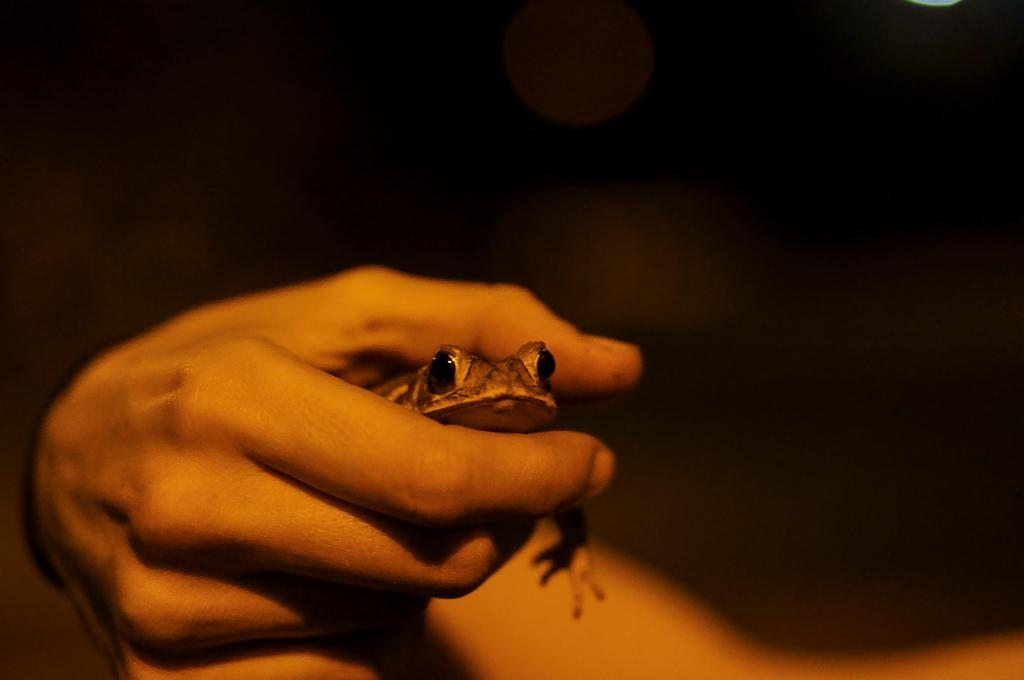What is the main subject of the image? The main subject of the image is a person. What is the person holding in the image? The person is holding a frog. What is the color of the background in the image? The background of the image is black. How does the person in the image end the frog's life? There is no indication in the image that the person is ending the frog's life, nor is there any visible method of doing so. 